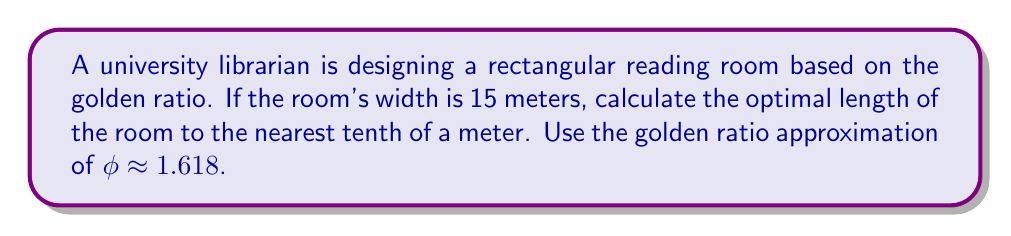Teach me how to tackle this problem. To solve this problem, we'll follow these steps:

1) The golden ratio, $\phi$, is defined as the ratio of the longer side to the shorter side of a rectangle. In this case:

   $\phi = \frac{\text{length}}{\text{width}}$

2) We're given that $\phi \approx 1.618$ and the width is 15 meters. Let's call the length $L$. We can set up the equation:

   $1.618 = \frac{L}{15}$

3) To solve for $L$, multiply both sides by 15:

   $1.618 \times 15 = L$

4) Perform the multiplication:

   $24.27 = L$

5) Rounding to the nearest tenth of a meter:

   $L \approx 24.3$ meters

Therefore, the optimal length of the reading room based on the golden ratio principle is approximately 24.3 meters.

[asy]
unitsize(10mm);
draw((0,0)--(15,0)--(15,24.3)--(0,24.3)--cycle);
label("15 m", (7.5,0), S);
label("24.3 m", (15,12.15), E);
label("Reading Room", (7.5,12.15), (0,0));
[/asy]
Answer: 24.3 meters 